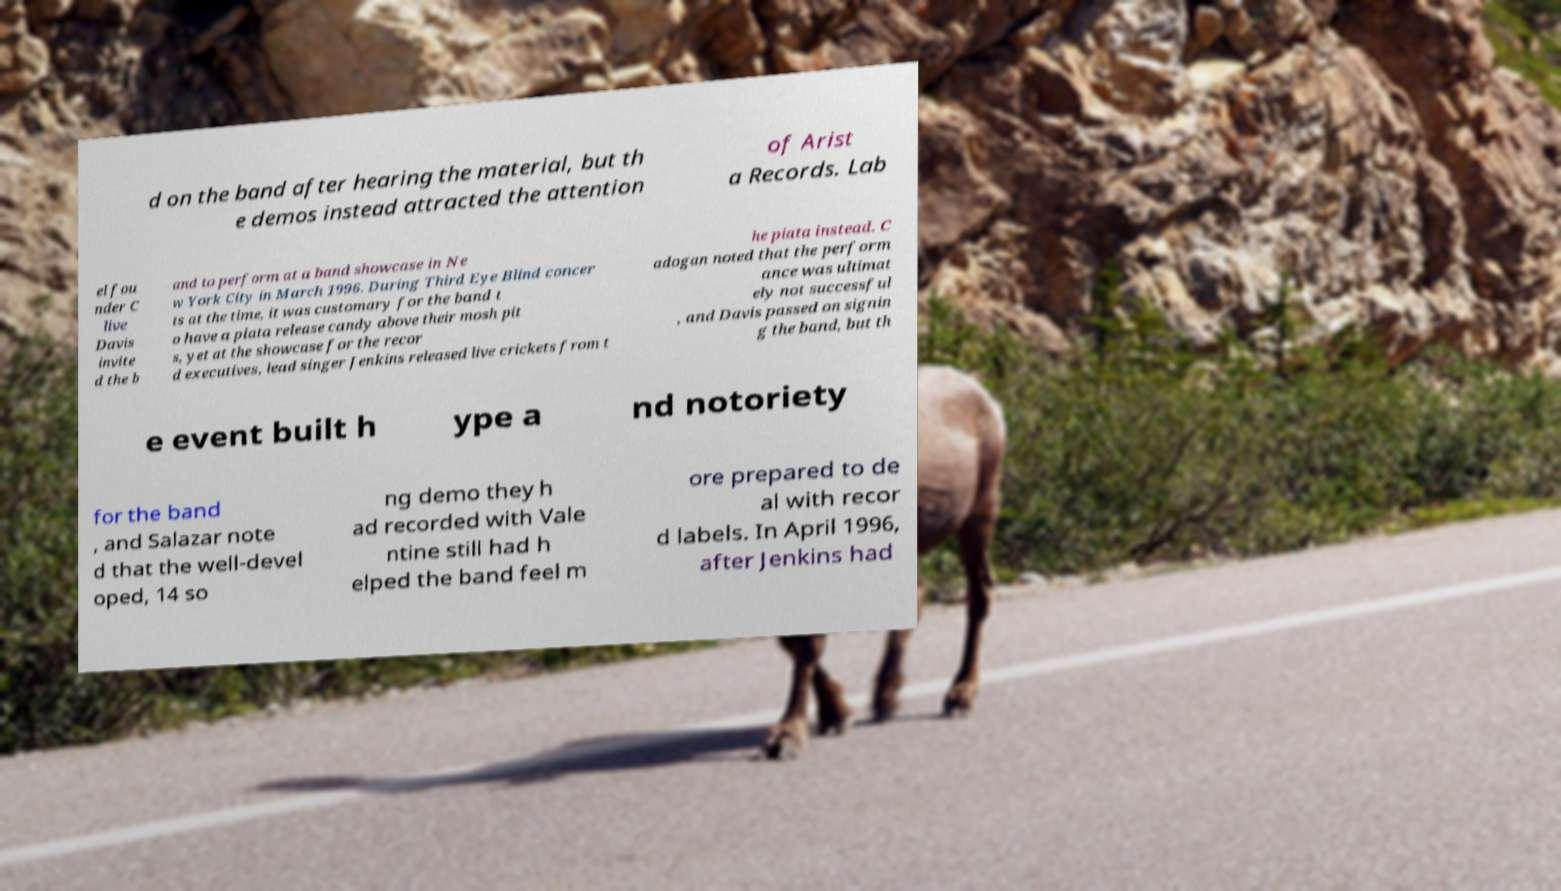Can you accurately transcribe the text from the provided image for me? d on the band after hearing the material, but th e demos instead attracted the attention of Arist a Records. Lab el fou nder C live Davis invite d the b and to perform at a band showcase in Ne w York City in March 1996. During Third Eye Blind concer ts at the time, it was customary for the band t o have a piata release candy above their mosh pit s, yet at the showcase for the recor d executives, lead singer Jenkins released live crickets from t he piata instead. C adogan noted that the perform ance was ultimat ely not successful , and Davis passed on signin g the band, but th e event built h ype a nd notoriety for the band , and Salazar note d that the well-devel oped, 14 so ng demo they h ad recorded with Vale ntine still had h elped the band feel m ore prepared to de al with recor d labels. In April 1996, after Jenkins had 